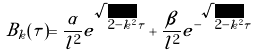<formula> <loc_0><loc_0><loc_500><loc_500>B _ { k } ( \tau ) = \frac { \alpha } { l ^ { 2 } } e ^ { \sqrt { 2 - k ^ { 2 } } \tau } + \frac { \beta } { l ^ { 2 } } e ^ { - \sqrt { 2 - k ^ { 2 } } \tau }</formula> 